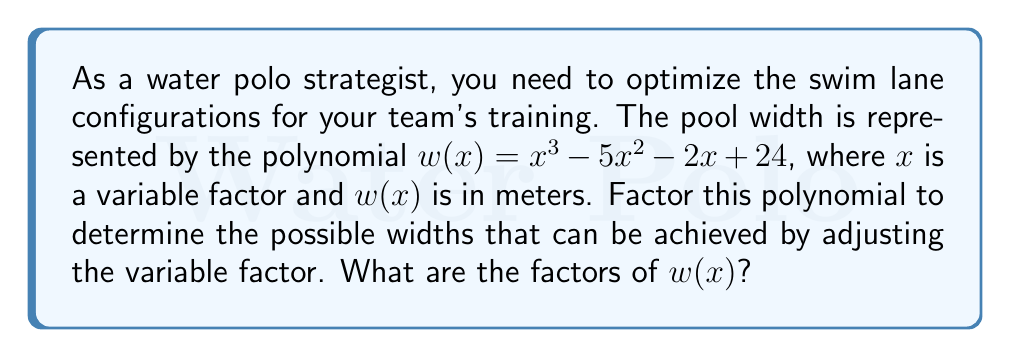Give your solution to this math problem. Let's approach this step-by-step:

1) First, we need to check if there are any common factors. In this case, there are none.

2) Next, we can try to guess one factor. Since 24 is the constant term, possible factors could be ±1, ±2, ±3, ±4, ±6, ±8, ±12, or ±24. Let's try these:

   $w(1) = 1 - 5 - 2 + 24 = 18$
   $w(2) = 8 - 20 - 4 + 24 = 8$
   $w(3) = 27 - 45 - 6 + 24 = 0$

3) We found that $(x - 3)$ is a factor. Let's use polynomial long division to find the other factor:

   $$\frac{x^3 - 5x^2 - 2x + 24}{x - 3} = x^2 - 2x - 8$$

4) So now we have: $w(x) = (x - 3)(x^2 - 2x - 8)$

5) We can factor the quadratic term $(x^2 - 2x - 8)$ further:
   
   $ac = (-1)(-8) = 8$
   $8 = 4 + 4$
   
   So, $x^2 - 2x - 8 = (x - 4)(x + 2)$

6) Therefore, the complete factorization is:

   $w(x) = (x - 3)(x - 4)(x + 2)$
Answer: $w(x) = (x - 3)(x - 4)(x + 2)$ 